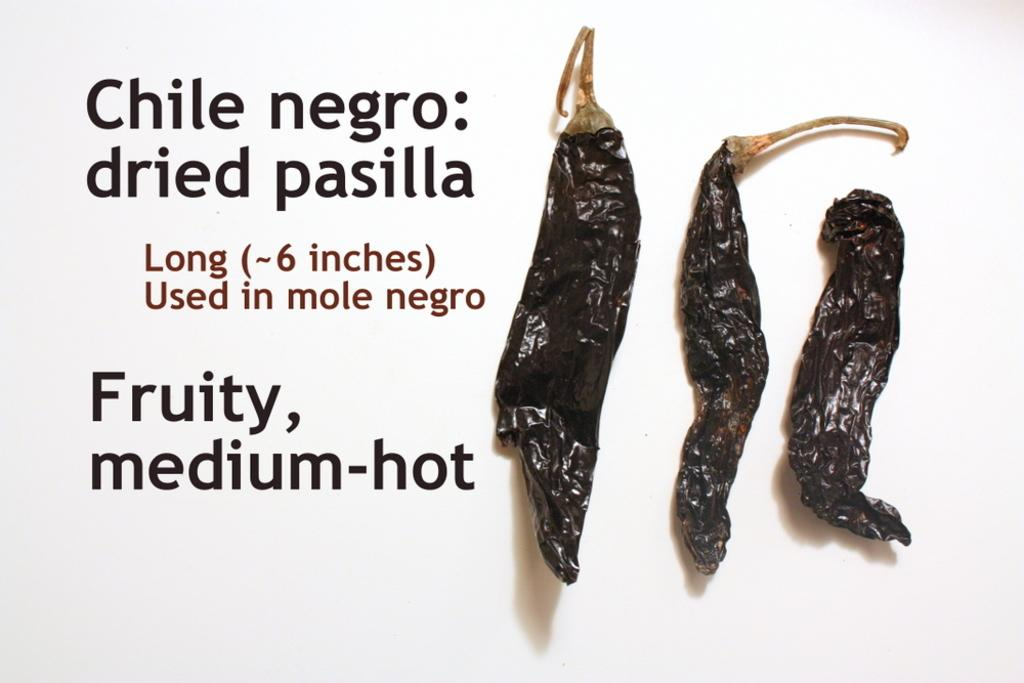What type of food item is visible in the image? There are dry chillies in the image. What else can be seen in the image besides the chillies? There is text in the image. What color is the background of the image? The background of the image is white. What type of rod is being used to stir the drink in the image? There is no drink or rod present in the image; it features dry chillies and text on a white background. 